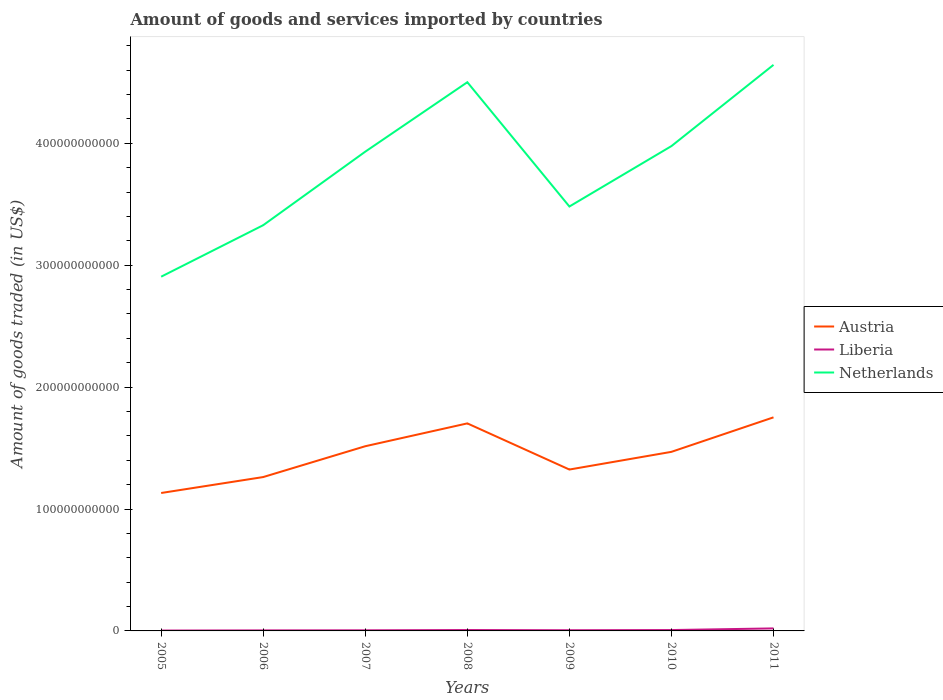Does the line corresponding to Liberia intersect with the line corresponding to Austria?
Offer a terse response. No. Across all years, what is the maximum total amount of goods and services imported in Netherlands?
Offer a very short reply. 2.91e+11. What is the total total amount of goods and services imported in Austria in the graph?
Offer a very short reply. -1.45e+1. What is the difference between the highest and the second highest total amount of goods and services imported in Austria?
Your answer should be compact. 6.21e+1. What is the difference between the highest and the lowest total amount of goods and services imported in Netherlands?
Offer a very short reply. 4. How many lines are there?
Your answer should be very brief. 3. What is the difference between two consecutive major ticks on the Y-axis?
Your answer should be compact. 1.00e+11. Are the values on the major ticks of Y-axis written in scientific E-notation?
Make the answer very short. No. Does the graph contain grids?
Your answer should be compact. No. Where does the legend appear in the graph?
Offer a very short reply. Center right. How are the legend labels stacked?
Give a very brief answer. Vertical. What is the title of the graph?
Give a very brief answer. Amount of goods and services imported by countries. What is the label or title of the Y-axis?
Make the answer very short. Amount of goods traded (in US$). What is the Amount of goods traded (in US$) in Austria in 2005?
Your response must be concise. 1.13e+11. What is the Amount of goods traded (in US$) of Liberia in 2005?
Provide a short and direct response. 3.06e+08. What is the Amount of goods traded (in US$) of Netherlands in 2005?
Ensure brevity in your answer.  2.91e+11. What is the Amount of goods traded (in US$) in Austria in 2006?
Keep it short and to the point. 1.26e+11. What is the Amount of goods traded (in US$) of Liberia in 2006?
Offer a terse response. 4.41e+08. What is the Amount of goods traded (in US$) of Netherlands in 2006?
Your response must be concise. 3.33e+11. What is the Amount of goods traded (in US$) in Austria in 2007?
Provide a short and direct response. 1.52e+11. What is the Amount of goods traded (in US$) of Liberia in 2007?
Make the answer very short. 4.98e+08. What is the Amount of goods traded (in US$) in Netherlands in 2007?
Give a very brief answer. 3.93e+11. What is the Amount of goods traded (in US$) in Austria in 2008?
Keep it short and to the point. 1.70e+11. What is the Amount of goods traded (in US$) in Liberia in 2008?
Offer a terse response. 7.29e+08. What is the Amount of goods traded (in US$) in Netherlands in 2008?
Ensure brevity in your answer.  4.50e+11. What is the Amount of goods traded (in US$) of Austria in 2009?
Give a very brief answer. 1.32e+11. What is the Amount of goods traded (in US$) of Liberia in 2009?
Offer a terse response. 5.59e+08. What is the Amount of goods traded (in US$) in Netherlands in 2009?
Your answer should be very brief. 3.48e+11. What is the Amount of goods traded (in US$) of Austria in 2010?
Keep it short and to the point. 1.47e+11. What is the Amount of goods traded (in US$) in Liberia in 2010?
Your response must be concise. 7.19e+08. What is the Amount of goods traded (in US$) in Netherlands in 2010?
Provide a succinct answer. 3.98e+11. What is the Amount of goods traded (in US$) in Austria in 2011?
Your answer should be compact. 1.75e+11. What is the Amount of goods traded (in US$) of Liberia in 2011?
Your response must be concise. 2.07e+09. What is the Amount of goods traded (in US$) of Netherlands in 2011?
Make the answer very short. 4.64e+11. Across all years, what is the maximum Amount of goods traded (in US$) in Austria?
Your answer should be compact. 1.75e+11. Across all years, what is the maximum Amount of goods traded (in US$) of Liberia?
Your answer should be compact. 2.07e+09. Across all years, what is the maximum Amount of goods traded (in US$) in Netherlands?
Give a very brief answer. 4.64e+11. Across all years, what is the minimum Amount of goods traded (in US$) in Austria?
Provide a succinct answer. 1.13e+11. Across all years, what is the minimum Amount of goods traded (in US$) in Liberia?
Provide a short and direct response. 3.06e+08. Across all years, what is the minimum Amount of goods traded (in US$) in Netherlands?
Make the answer very short. 2.91e+11. What is the total Amount of goods traded (in US$) of Austria in the graph?
Make the answer very short. 1.02e+12. What is the total Amount of goods traded (in US$) in Liberia in the graph?
Your answer should be compact. 5.32e+09. What is the total Amount of goods traded (in US$) of Netherlands in the graph?
Your answer should be very brief. 2.68e+12. What is the difference between the Amount of goods traded (in US$) in Austria in 2005 and that in 2006?
Make the answer very short. -1.31e+1. What is the difference between the Amount of goods traded (in US$) in Liberia in 2005 and that in 2006?
Offer a terse response. -1.35e+08. What is the difference between the Amount of goods traded (in US$) of Netherlands in 2005 and that in 2006?
Offer a terse response. -4.23e+1. What is the difference between the Amount of goods traded (in US$) in Austria in 2005 and that in 2007?
Provide a succinct answer. -3.84e+1. What is the difference between the Amount of goods traded (in US$) of Liberia in 2005 and that in 2007?
Offer a very short reply. -1.92e+08. What is the difference between the Amount of goods traded (in US$) of Netherlands in 2005 and that in 2007?
Provide a short and direct response. -1.03e+11. What is the difference between the Amount of goods traded (in US$) in Austria in 2005 and that in 2008?
Your answer should be very brief. -5.71e+1. What is the difference between the Amount of goods traded (in US$) in Liberia in 2005 and that in 2008?
Provide a short and direct response. -4.22e+08. What is the difference between the Amount of goods traded (in US$) in Netherlands in 2005 and that in 2008?
Ensure brevity in your answer.  -1.60e+11. What is the difference between the Amount of goods traded (in US$) of Austria in 2005 and that in 2009?
Offer a terse response. -1.92e+1. What is the difference between the Amount of goods traded (in US$) in Liberia in 2005 and that in 2009?
Give a very brief answer. -2.53e+08. What is the difference between the Amount of goods traded (in US$) of Netherlands in 2005 and that in 2009?
Provide a succinct answer. -5.76e+1. What is the difference between the Amount of goods traded (in US$) of Austria in 2005 and that in 2010?
Offer a very short reply. -3.38e+1. What is the difference between the Amount of goods traded (in US$) of Liberia in 2005 and that in 2010?
Keep it short and to the point. -4.13e+08. What is the difference between the Amount of goods traded (in US$) of Netherlands in 2005 and that in 2010?
Your response must be concise. -1.07e+11. What is the difference between the Amount of goods traded (in US$) of Austria in 2005 and that in 2011?
Ensure brevity in your answer.  -6.21e+1. What is the difference between the Amount of goods traded (in US$) of Liberia in 2005 and that in 2011?
Your answer should be very brief. -1.76e+09. What is the difference between the Amount of goods traded (in US$) of Netherlands in 2005 and that in 2011?
Make the answer very short. -1.74e+11. What is the difference between the Amount of goods traded (in US$) in Austria in 2006 and that in 2007?
Your response must be concise. -2.53e+1. What is the difference between the Amount of goods traded (in US$) in Liberia in 2006 and that in 2007?
Your answer should be compact. -5.74e+07. What is the difference between the Amount of goods traded (in US$) of Netherlands in 2006 and that in 2007?
Your response must be concise. -6.03e+1. What is the difference between the Amount of goods traded (in US$) of Austria in 2006 and that in 2008?
Your response must be concise. -4.40e+1. What is the difference between the Amount of goods traded (in US$) in Liberia in 2006 and that in 2008?
Offer a terse response. -2.88e+08. What is the difference between the Amount of goods traded (in US$) in Netherlands in 2006 and that in 2008?
Provide a short and direct response. -1.17e+11. What is the difference between the Amount of goods traded (in US$) of Austria in 2006 and that in 2009?
Offer a terse response. -6.16e+09. What is the difference between the Amount of goods traded (in US$) of Liberia in 2006 and that in 2009?
Give a very brief answer. -1.18e+08. What is the difference between the Amount of goods traded (in US$) of Netherlands in 2006 and that in 2009?
Give a very brief answer. -1.53e+1. What is the difference between the Amount of goods traded (in US$) of Austria in 2006 and that in 2010?
Your answer should be very brief. -2.07e+1. What is the difference between the Amount of goods traded (in US$) of Liberia in 2006 and that in 2010?
Make the answer very short. -2.78e+08. What is the difference between the Amount of goods traded (in US$) in Netherlands in 2006 and that in 2010?
Your answer should be compact. -6.49e+1. What is the difference between the Amount of goods traded (in US$) in Austria in 2006 and that in 2011?
Provide a succinct answer. -4.90e+1. What is the difference between the Amount of goods traded (in US$) of Liberia in 2006 and that in 2011?
Give a very brief answer. -1.63e+09. What is the difference between the Amount of goods traded (in US$) in Netherlands in 2006 and that in 2011?
Provide a succinct answer. -1.32e+11. What is the difference between the Amount of goods traded (in US$) in Austria in 2007 and that in 2008?
Keep it short and to the point. -1.87e+1. What is the difference between the Amount of goods traded (in US$) in Liberia in 2007 and that in 2008?
Provide a succinct answer. -2.30e+08. What is the difference between the Amount of goods traded (in US$) of Netherlands in 2007 and that in 2008?
Provide a short and direct response. -5.70e+1. What is the difference between the Amount of goods traded (in US$) of Austria in 2007 and that in 2009?
Make the answer very short. 1.91e+1. What is the difference between the Amount of goods traded (in US$) in Liberia in 2007 and that in 2009?
Keep it short and to the point. -6.05e+07. What is the difference between the Amount of goods traded (in US$) in Netherlands in 2007 and that in 2009?
Your response must be concise. 4.50e+1. What is the difference between the Amount of goods traded (in US$) of Austria in 2007 and that in 2010?
Keep it short and to the point. 4.60e+09. What is the difference between the Amount of goods traded (in US$) in Liberia in 2007 and that in 2010?
Provide a short and direct response. -2.21e+08. What is the difference between the Amount of goods traded (in US$) of Netherlands in 2007 and that in 2010?
Your response must be concise. -4.58e+09. What is the difference between the Amount of goods traded (in US$) of Austria in 2007 and that in 2011?
Your answer should be compact. -2.37e+1. What is the difference between the Amount of goods traded (in US$) of Liberia in 2007 and that in 2011?
Keep it short and to the point. -1.57e+09. What is the difference between the Amount of goods traded (in US$) of Netherlands in 2007 and that in 2011?
Give a very brief answer. -7.12e+1. What is the difference between the Amount of goods traded (in US$) of Austria in 2008 and that in 2009?
Provide a short and direct response. 3.79e+1. What is the difference between the Amount of goods traded (in US$) of Liberia in 2008 and that in 2009?
Your response must be concise. 1.70e+08. What is the difference between the Amount of goods traded (in US$) in Netherlands in 2008 and that in 2009?
Keep it short and to the point. 1.02e+11. What is the difference between the Amount of goods traded (in US$) in Austria in 2008 and that in 2010?
Your response must be concise. 2.33e+1. What is the difference between the Amount of goods traded (in US$) in Liberia in 2008 and that in 2010?
Provide a short and direct response. 9.73e+06. What is the difference between the Amount of goods traded (in US$) in Netherlands in 2008 and that in 2010?
Offer a terse response. 5.24e+1. What is the difference between the Amount of goods traded (in US$) of Austria in 2008 and that in 2011?
Give a very brief answer. -4.96e+09. What is the difference between the Amount of goods traded (in US$) in Liberia in 2008 and that in 2011?
Make the answer very short. -1.34e+09. What is the difference between the Amount of goods traded (in US$) of Netherlands in 2008 and that in 2011?
Provide a succinct answer. -1.42e+1. What is the difference between the Amount of goods traded (in US$) of Austria in 2009 and that in 2010?
Your answer should be very brief. -1.45e+1. What is the difference between the Amount of goods traded (in US$) of Liberia in 2009 and that in 2010?
Your answer should be compact. -1.60e+08. What is the difference between the Amount of goods traded (in US$) of Netherlands in 2009 and that in 2010?
Your response must be concise. -4.96e+1. What is the difference between the Amount of goods traded (in US$) of Austria in 2009 and that in 2011?
Give a very brief answer. -4.28e+1. What is the difference between the Amount of goods traded (in US$) in Liberia in 2009 and that in 2011?
Your answer should be compact. -1.51e+09. What is the difference between the Amount of goods traded (in US$) of Netherlands in 2009 and that in 2011?
Give a very brief answer. -1.16e+11. What is the difference between the Amount of goods traded (in US$) of Austria in 2010 and that in 2011?
Keep it short and to the point. -2.83e+1. What is the difference between the Amount of goods traded (in US$) in Liberia in 2010 and that in 2011?
Offer a very short reply. -1.35e+09. What is the difference between the Amount of goods traded (in US$) of Netherlands in 2010 and that in 2011?
Provide a short and direct response. -6.66e+1. What is the difference between the Amount of goods traded (in US$) in Austria in 2005 and the Amount of goods traded (in US$) in Liberia in 2006?
Make the answer very short. 1.13e+11. What is the difference between the Amount of goods traded (in US$) in Austria in 2005 and the Amount of goods traded (in US$) in Netherlands in 2006?
Offer a very short reply. -2.20e+11. What is the difference between the Amount of goods traded (in US$) of Liberia in 2005 and the Amount of goods traded (in US$) of Netherlands in 2006?
Provide a short and direct response. -3.33e+11. What is the difference between the Amount of goods traded (in US$) of Austria in 2005 and the Amount of goods traded (in US$) of Liberia in 2007?
Your response must be concise. 1.13e+11. What is the difference between the Amount of goods traded (in US$) in Austria in 2005 and the Amount of goods traded (in US$) in Netherlands in 2007?
Make the answer very short. -2.80e+11. What is the difference between the Amount of goods traded (in US$) of Liberia in 2005 and the Amount of goods traded (in US$) of Netherlands in 2007?
Offer a very short reply. -3.93e+11. What is the difference between the Amount of goods traded (in US$) of Austria in 2005 and the Amount of goods traded (in US$) of Liberia in 2008?
Keep it short and to the point. 1.12e+11. What is the difference between the Amount of goods traded (in US$) of Austria in 2005 and the Amount of goods traded (in US$) of Netherlands in 2008?
Your response must be concise. -3.37e+11. What is the difference between the Amount of goods traded (in US$) in Liberia in 2005 and the Amount of goods traded (in US$) in Netherlands in 2008?
Give a very brief answer. -4.50e+11. What is the difference between the Amount of goods traded (in US$) of Austria in 2005 and the Amount of goods traded (in US$) of Liberia in 2009?
Your response must be concise. 1.13e+11. What is the difference between the Amount of goods traded (in US$) in Austria in 2005 and the Amount of goods traded (in US$) in Netherlands in 2009?
Give a very brief answer. -2.35e+11. What is the difference between the Amount of goods traded (in US$) in Liberia in 2005 and the Amount of goods traded (in US$) in Netherlands in 2009?
Your answer should be compact. -3.48e+11. What is the difference between the Amount of goods traded (in US$) of Austria in 2005 and the Amount of goods traded (in US$) of Liberia in 2010?
Keep it short and to the point. 1.12e+11. What is the difference between the Amount of goods traded (in US$) of Austria in 2005 and the Amount of goods traded (in US$) of Netherlands in 2010?
Make the answer very short. -2.85e+11. What is the difference between the Amount of goods traded (in US$) of Liberia in 2005 and the Amount of goods traded (in US$) of Netherlands in 2010?
Your response must be concise. -3.97e+11. What is the difference between the Amount of goods traded (in US$) in Austria in 2005 and the Amount of goods traded (in US$) in Liberia in 2011?
Your answer should be compact. 1.11e+11. What is the difference between the Amount of goods traded (in US$) of Austria in 2005 and the Amount of goods traded (in US$) of Netherlands in 2011?
Provide a succinct answer. -3.51e+11. What is the difference between the Amount of goods traded (in US$) of Liberia in 2005 and the Amount of goods traded (in US$) of Netherlands in 2011?
Offer a very short reply. -4.64e+11. What is the difference between the Amount of goods traded (in US$) of Austria in 2006 and the Amount of goods traded (in US$) of Liberia in 2007?
Keep it short and to the point. 1.26e+11. What is the difference between the Amount of goods traded (in US$) of Austria in 2006 and the Amount of goods traded (in US$) of Netherlands in 2007?
Offer a very short reply. -2.67e+11. What is the difference between the Amount of goods traded (in US$) in Liberia in 2006 and the Amount of goods traded (in US$) in Netherlands in 2007?
Ensure brevity in your answer.  -3.93e+11. What is the difference between the Amount of goods traded (in US$) in Austria in 2006 and the Amount of goods traded (in US$) in Liberia in 2008?
Your answer should be very brief. 1.25e+11. What is the difference between the Amount of goods traded (in US$) in Austria in 2006 and the Amount of goods traded (in US$) in Netherlands in 2008?
Offer a very short reply. -3.24e+11. What is the difference between the Amount of goods traded (in US$) in Liberia in 2006 and the Amount of goods traded (in US$) in Netherlands in 2008?
Give a very brief answer. -4.50e+11. What is the difference between the Amount of goods traded (in US$) in Austria in 2006 and the Amount of goods traded (in US$) in Liberia in 2009?
Ensure brevity in your answer.  1.26e+11. What is the difference between the Amount of goods traded (in US$) in Austria in 2006 and the Amount of goods traded (in US$) in Netherlands in 2009?
Offer a very short reply. -2.22e+11. What is the difference between the Amount of goods traded (in US$) in Liberia in 2006 and the Amount of goods traded (in US$) in Netherlands in 2009?
Offer a terse response. -3.48e+11. What is the difference between the Amount of goods traded (in US$) of Austria in 2006 and the Amount of goods traded (in US$) of Liberia in 2010?
Keep it short and to the point. 1.26e+11. What is the difference between the Amount of goods traded (in US$) of Austria in 2006 and the Amount of goods traded (in US$) of Netherlands in 2010?
Your answer should be very brief. -2.72e+11. What is the difference between the Amount of goods traded (in US$) of Liberia in 2006 and the Amount of goods traded (in US$) of Netherlands in 2010?
Offer a very short reply. -3.97e+11. What is the difference between the Amount of goods traded (in US$) in Austria in 2006 and the Amount of goods traded (in US$) in Liberia in 2011?
Offer a terse response. 1.24e+11. What is the difference between the Amount of goods traded (in US$) in Austria in 2006 and the Amount of goods traded (in US$) in Netherlands in 2011?
Provide a succinct answer. -3.38e+11. What is the difference between the Amount of goods traded (in US$) of Liberia in 2006 and the Amount of goods traded (in US$) of Netherlands in 2011?
Your answer should be compact. -4.64e+11. What is the difference between the Amount of goods traded (in US$) of Austria in 2007 and the Amount of goods traded (in US$) of Liberia in 2008?
Offer a very short reply. 1.51e+11. What is the difference between the Amount of goods traded (in US$) in Austria in 2007 and the Amount of goods traded (in US$) in Netherlands in 2008?
Make the answer very short. -2.99e+11. What is the difference between the Amount of goods traded (in US$) in Liberia in 2007 and the Amount of goods traded (in US$) in Netherlands in 2008?
Give a very brief answer. -4.50e+11. What is the difference between the Amount of goods traded (in US$) in Austria in 2007 and the Amount of goods traded (in US$) in Liberia in 2009?
Your answer should be compact. 1.51e+11. What is the difference between the Amount of goods traded (in US$) in Austria in 2007 and the Amount of goods traded (in US$) in Netherlands in 2009?
Your response must be concise. -1.97e+11. What is the difference between the Amount of goods traded (in US$) of Liberia in 2007 and the Amount of goods traded (in US$) of Netherlands in 2009?
Offer a very short reply. -3.48e+11. What is the difference between the Amount of goods traded (in US$) of Austria in 2007 and the Amount of goods traded (in US$) of Liberia in 2010?
Offer a very short reply. 1.51e+11. What is the difference between the Amount of goods traded (in US$) in Austria in 2007 and the Amount of goods traded (in US$) in Netherlands in 2010?
Keep it short and to the point. -2.46e+11. What is the difference between the Amount of goods traded (in US$) in Liberia in 2007 and the Amount of goods traded (in US$) in Netherlands in 2010?
Offer a very short reply. -3.97e+11. What is the difference between the Amount of goods traded (in US$) of Austria in 2007 and the Amount of goods traded (in US$) of Liberia in 2011?
Keep it short and to the point. 1.49e+11. What is the difference between the Amount of goods traded (in US$) of Austria in 2007 and the Amount of goods traded (in US$) of Netherlands in 2011?
Your answer should be compact. -3.13e+11. What is the difference between the Amount of goods traded (in US$) of Liberia in 2007 and the Amount of goods traded (in US$) of Netherlands in 2011?
Give a very brief answer. -4.64e+11. What is the difference between the Amount of goods traded (in US$) of Austria in 2008 and the Amount of goods traded (in US$) of Liberia in 2009?
Make the answer very short. 1.70e+11. What is the difference between the Amount of goods traded (in US$) of Austria in 2008 and the Amount of goods traded (in US$) of Netherlands in 2009?
Offer a terse response. -1.78e+11. What is the difference between the Amount of goods traded (in US$) in Liberia in 2008 and the Amount of goods traded (in US$) in Netherlands in 2009?
Give a very brief answer. -3.47e+11. What is the difference between the Amount of goods traded (in US$) in Austria in 2008 and the Amount of goods traded (in US$) in Liberia in 2010?
Provide a short and direct response. 1.70e+11. What is the difference between the Amount of goods traded (in US$) in Austria in 2008 and the Amount of goods traded (in US$) in Netherlands in 2010?
Your answer should be very brief. -2.27e+11. What is the difference between the Amount of goods traded (in US$) in Liberia in 2008 and the Amount of goods traded (in US$) in Netherlands in 2010?
Provide a short and direct response. -3.97e+11. What is the difference between the Amount of goods traded (in US$) of Austria in 2008 and the Amount of goods traded (in US$) of Liberia in 2011?
Your response must be concise. 1.68e+11. What is the difference between the Amount of goods traded (in US$) of Austria in 2008 and the Amount of goods traded (in US$) of Netherlands in 2011?
Ensure brevity in your answer.  -2.94e+11. What is the difference between the Amount of goods traded (in US$) of Liberia in 2008 and the Amount of goods traded (in US$) of Netherlands in 2011?
Offer a very short reply. -4.64e+11. What is the difference between the Amount of goods traded (in US$) in Austria in 2009 and the Amount of goods traded (in US$) in Liberia in 2010?
Make the answer very short. 1.32e+11. What is the difference between the Amount of goods traded (in US$) in Austria in 2009 and the Amount of goods traded (in US$) in Netherlands in 2010?
Ensure brevity in your answer.  -2.65e+11. What is the difference between the Amount of goods traded (in US$) of Liberia in 2009 and the Amount of goods traded (in US$) of Netherlands in 2010?
Your answer should be compact. -3.97e+11. What is the difference between the Amount of goods traded (in US$) in Austria in 2009 and the Amount of goods traded (in US$) in Liberia in 2011?
Your response must be concise. 1.30e+11. What is the difference between the Amount of goods traded (in US$) of Austria in 2009 and the Amount of goods traded (in US$) of Netherlands in 2011?
Give a very brief answer. -3.32e+11. What is the difference between the Amount of goods traded (in US$) of Liberia in 2009 and the Amount of goods traded (in US$) of Netherlands in 2011?
Give a very brief answer. -4.64e+11. What is the difference between the Amount of goods traded (in US$) in Austria in 2010 and the Amount of goods traded (in US$) in Liberia in 2011?
Offer a terse response. 1.45e+11. What is the difference between the Amount of goods traded (in US$) in Austria in 2010 and the Amount of goods traded (in US$) in Netherlands in 2011?
Your response must be concise. -3.17e+11. What is the difference between the Amount of goods traded (in US$) of Liberia in 2010 and the Amount of goods traded (in US$) of Netherlands in 2011?
Provide a short and direct response. -4.64e+11. What is the average Amount of goods traded (in US$) of Austria per year?
Give a very brief answer. 1.45e+11. What is the average Amount of goods traded (in US$) in Liberia per year?
Your answer should be compact. 7.60e+08. What is the average Amount of goods traded (in US$) in Netherlands per year?
Make the answer very short. 3.82e+11. In the year 2005, what is the difference between the Amount of goods traded (in US$) in Austria and Amount of goods traded (in US$) in Liberia?
Your answer should be very brief. 1.13e+11. In the year 2005, what is the difference between the Amount of goods traded (in US$) in Austria and Amount of goods traded (in US$) in Netherlands?
Your answer should be very brief. -1.77e+11. In the year 2005, what is the difference between the Amount of goods traded (in US$) in Liberia and Amount of goods traded (in US$) in Netherlands?
Keep it short and to the point. -2.90e+11. In the year 2006, what is the difference between the Amount of goods traded (in US$) of Austria and Amount of goods traded (in US$) of Liberia?
Give a very brief answer. 1.26e+11. In the year 2006, what is the difference between the Amount of goods traded (in US$) in Austria and Amount of goods traded (in US$) in Netherlands?
Your answer should be compact. -2.07e+11. In the year 2006, what is the difference between the Amount of goods traded (in US$) in Liberia and Amount of goods traded (in US$) in Netherlands?
Keep it short and to the point. -3.32e+11. In the year 2007, what is the difference between the Amount of goods traded (in US$) in Austria and Amount of goods traded (in US$) in Liberia?
Provide a succinct answer. 1.51e+11. In the year 2007, what is the difference between the Amount of goods traded (in US$) in Austria and Amount of goods traded (in US$) in Netherlands?
Give a very brief answer. -2.42e+11. In the year 2007, what is the difference between the Amount of goods traded (in US$) of Liberia and Amount of goods traded (in US$) of Netherlands?
Keep it short and to the point. -3.93e+11. In the year 2008, what is the difference between the Amount of goods traded (in US$) in Austria and Amount of goods traded (in US$) in Liberia?
Keep it short and to the point. 1.70e+11. In the year 2008, what is the difference between the Amount of goods traded (in US$) in Austria and Amount of goods traded (in US$) in Netherlands?
Make the answer very short. -2.80e+11. In the year 2008, what is the difference between the Amount of goods traded (in US$) in Liberia and Amount of goods traded (in US$) in Netherlands?
Your response must be concise. -4.49e+11. In the year 2009, what is the difference between the Amount of goods traded (in US$) in Austria and Amount of goods traded (in US$) in Liberia?
Offer a terse response. 1.32e+11. In the year 2009, what is the difference between the Amount of goods traded (in US$) in Austria and Amount of goods traded (in US$) in Netherlands?
Your answer should be very brief. -2.16e+11. In the year 2009, what is the difference between the Amount of goods traded (in US$) in Liberia and Amount of goods traded (in US$) in Netherlands?
Your answer should be very brief. -3.48e+11. In the year 2010, what is the difference between the Amount of goods traded (in US$) of Austria and Amount of goods traded (in US$) of Liberia?
Keep it short and to the point. 1.46e+11. In the year 2010, what is the difference between the Amount of goods traded (in US$) of Austria and Amount of goods traded (in US$) of Netherlands?
Make the answer very short. -2.51e+11. In the year 2010, what is the difference between the Amount of goods traded (in US$) of Liberia and Amount of goods traded (in US$) of Netherlands?
Offer a terse response. -3.97e+11. In the year 2011, what is the difference between the Amount of goods traded (in US$) in Austria and Amount of goods traded (in US$) in Liberia?
Offer a terse response. 1.73e+11. In the year 2011, what is the difference between the Amount of goods traded (in US$) of Austria and Amount of goods traded (in US$) of Netherlands?
Offer a terse response. -2.89e+11. In the year 2011, what is the difference between the Amount of goods traded (in US$) in Liberia and Amount of goods traded (in US$) in Netherlands?
Provide a succinct answer. -4.62e+11. What is the ratio of the Amount of goods traded (in US$) of Austria in 2005 to that in 2006?
Your answer should be very brief. 0.9. What is the ratio of the Amount of goods traded (in US$) in Liberia in 2005 to that in 2006?
Give a very brief answer. 0.69. What is the ratio of the Amount of goods traded (in US$) of Netherlands in 2005 to that in 2006?
Your answer should be compact. 0.87. What is the ratio of the Amount of goods traded (in US$) in Austria in 2005 to that in 2007?
Provide a short and direct response. 0.75. What is the ratio of the Amount of goods traded (in US$) of Liberia in 2005 to that in 2007?
Keep it short and to the point. 0.61. What is the ratio of the Amount of goods traded (in US$) in Netherlands in 2005 to that in 2007?
Your response must be concise. 0.74. What is the ratio of the Amount of goods traded (in US$) in Austria in 2005 to that in 2008?
Offer a terse response. 0.66. What is the ratio of the Amount of goods traded (in US$) in Liberia in 2005 to that in 2008?
Provide a succinct answer. 0.42. What is the ratio of the Amount of goods traded (in US$) of Netherlands in 2005 to that in 2008?
Provide a succinct answer. 0.65. What is the ratio of the Amount of goods traded (in US$) of Austria in 2005 to that in 2009?
Provide a succinct answer. 0.85. What is the ratio of the Amount of goods traded (in US$) of Liberia in 2005 to that in 2009?
Offer a terse response. 0.55. What is the ratio of the Amount of goods traded (in US$) of Netherlands in 2005 to that in 2009?
Offer a very short reply. 0.83. What is the ratio of the Amount of goods traded (in US$) of Austria in 2005 to that in 2010?
Provide a short and direct response. 0.77. What is the ratio of the Amount of goods traded (in US$) in Liberia in 2005 to that in 2010?
Your answer should be compact. 0.43. What is the ratio of the Amount of goods traded (in US$) of Netherlands in 2005 to that in 2010?
Your answer should be very brief. 0.73. What is the ratio of the Amount of goods traded (in US$) of Austria in 2005 to that in 2011?
Provide a short and direct response. 0.65. What is the ratio of the Amount of goods traded (in US$) in Liberia in 2005 to that in 2011?
Keep it short and to the point. 0.15. What is the ratio of the Amount of goods traded (in US$) of Netherlands in 2005 to that in 2011?
Offer a terse response. 0.63. What is the ratio of the Amount of goods traded (in US$) in Austria in 2006 to that in 2007?
Make the answer very short. 0.83. What is the ratio of the Amount of goods traded (in US$) of Liberia in 2006 to that in 2007?
Your response must be concise. 0.88. What is the ratio of the Amount of goods traded (in US$) in Netherlands in 2006 to that in 2007?
Make the answer very short. 0.85. What is the ratio of the Amount of goods traded (in US$) of Austria in 2006 to that in 2008?
Keep it short and to the point. 0.74. What is the ratio of the Amount of goods traded (in US$) in Liberia in 2006 to that in 2008?
Offer a very short reply. 0.61. What is the ratio of the Amount of goods traded (in US$) of Netherlands in 2006 to that in 2008?
Provide a succinct answer. 0.74. What is the ratio of the Amount of goods traded (in US$) in Austria in 2006 to that in 2009?
Offer a very short reply. 0.95. What is the ratio of the Amount of goods traded (in US$) of Liberia in 2006 to that in 2009?
Ensure brevity in your answer.  0.79. What is the ratio of the Amount of goods traded (in US$) in Netherlands in 2006 to that in 2009?
Offer a terse response. 0.96. What is the ratio of the Amount of goods traded (in US$) of Austria in 2006 to that in 2010?
Provide a short and direct response. 0.86. What is the ratio of the Amount of goods traded (in US$) in Liberia in 2006 to that in 2010?
Make the answer very short. 0.61. What is the ratio of the Amount of goods traded (in US$) of Netherlands in 2006 to that in 2010?
Offer a very short reply. 0.84. What is the ratio of the Amount of goods traded (in US$) of Austria in 2006 to that in 2011?
Make the answer very short. 0.72. What is the ratio of the Amount of goods traded (in US$) of Liberia in 2006 to that in 2011?
Your answer should be compact. 0.21. What is the ratio of the Amount of goods traded (in US$) of Netherlands in 2006 to that in 2011?
Your answer should be compact. 0.72. What is the ratio of the Amount of goods traded (in US$) of Austria in 2007 to that in 2008?
Your answer should be very brief. 0.89. What is the ratio of the Amount of goods traded (in US$) of Liberia in 2007 to that in 2008?
Make the answer very short. 0.68. What is the ratio of the Amount of goods traded (in US$) in Netherlands in 2007 to that in 2008?
Provide a succinct answer. 0.87. What is the ratio of the Amount of goods traded (in US$) in Austria in 2007 to that in 2009?
Your response must be concise. 1.14. What is the ratio of the Amount of goods traded (in US$) in Liberia in 2007 to that in 2009?
Make the answer very short. 0.89. What is the ratio of the Amount of goods traded (in US$) of Netherlands in 2007 to that in 2009?
Give a very brief answer. 1.13. What is the ratio of the Amount of goods traded (in US$) of Austria in 2007 to that in 2010?
Offer a terse response. 1.03. What is the ratio of the Amount of goods traded (in US$) of Liberia in 2007 to that in 2010?
Give a very brief answer. 0.69. What is the ratio of the Amount of goods traded (in US$) of Austria in 2007 to that in 2011?
Offer a terse response. 0.86. What is the ratio of the Amount of goods traded (in US$) in Liberia in 2007 to that in 2011?
Keep it short and to the point. 0.24. What is the ratio of the Amount of goods traded (in US$) in Netherlands in 2007 to that in 2011?
Offer a very short reply. 0.85. What is the ratio of the Amount of goods traded (in US$) in Austria in 2008 to that in 2009?
Your answer should be compact. 1.29. What is the ratio of the Amount of goods traded (in US$) in Liberia in 2008 to that in 2009?
Offer a terse response. 1.3. What is the ratio of the Amount of goods traded (in US$) of Netherlands in 2008 to that in 2009?
Offer a terse response. 1.29. What is the ratio of the Amount of goods traded (in US$) of Austria in 2008 to that in 2010?
Make the answer very short. 1.16. What is the ratio of the Amount of goods traded (in US$) of Liberia in 2008 to that in 2010?
Give a very brief answer. 1.01. What is the ratio of the Amount of goods traded (in US$) of Netherlands in 2008 to that in 2010?
Give a very brief answer. 1.13. What is the ratio of the Amount of goods traded (in US$) in Austria in 2008 to that in 2011?
Your answer should be very brief. 0.97. What is the ratio of the Amount of goods traded (in US$) of Liberia in 2008 to that in 2011?
Offer a terse response. 0.35. What is the ratio of the Amount of goods traded (in US$) in Netherlands in 2008 to that in 2011?
Keep it short and to the point. 0.97. What is the ratio of the Amount of goods traded (in US$) of Austria in 2009 to that in 2010?
Your response must be concise. 0.9. What is the ratio of the Amount of goods traded (in US$) in Liberia in 2009 to that in 2010?
Offer a terse response. 0.78. What is the ratio of the Amount of goods traded (in US$) of Netherlands in 2009 to that in 2010?
Offer a very short reply. 0.88. What is the ratio of the Amount of goods traded (in US$) in Austria in 2009 to that in 2011?
Your answer should be compact. 0.76. What is the ratio of the Amount of goods traded (in US$) of Liberia in 2009 to that in 2011?
Keep it short and to the point. 0.27. What is the ratio of the Amount of goods traded (in US$) of Netherlands in 2009 to that in 2011?
Provide a succinct answer. 0.75. What is the ratio of the Amount of goods traded (in US$) in Austria in 2010 to that in 2011?
Keep it short and to the point. 0.84. What is the ratio of the Amount of goods traded (in US$) in Liberia in 2010 to that in 2011?
Your answer should be compact. 0.35. What is the ratio of the Amount of goods traded (in US$) in Netherlands in 2010 to that in 2011?
Offer a terse response. 0.86. What is the difference between the highest and the second highest Amount of goods traded (in US$) of Austria?
Your response must be concise. 4.96e+09. What is the difference between the highest and the second highest Amount of goods traded (in US$) in Liberia?
Your answer should be very brief. 1.34e+09. What is the difference between the highest and the second highest Amount of goods traded (in US$) of Netherlands?
Provide a succinct answer. 1.42e+1. What is the difference between the highest and the lowest Amount of goods traded (in US$) in Austria?
Provide a short and direct response. 6.21e+1. What is the difference between the highest and the lowest Amount of goods traded (in US$) in Liberia?
Your answer should be compact. 1.76e+09. What is the difference between the highest and the lowest Amount of goods traded (in US$) of Netherlands?
Give a very brief answer. 1.74e+11. 